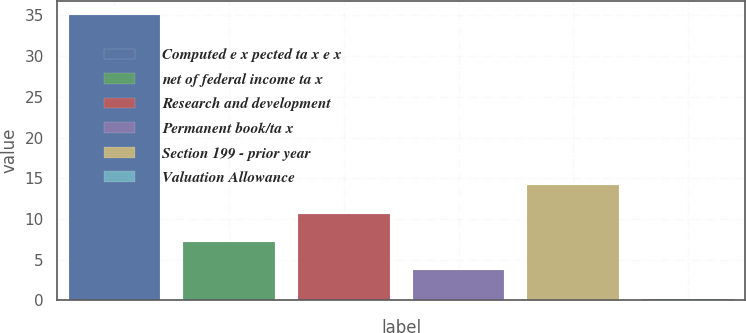Convert chart. <chart><loc_0><loc_0><loc_500><loc_500><bar_chart><fcel>Computed e x pected ta x e x<fcel>net of federal income ta x<fcel>Research and development<fcel>Permanent book/ta x<fcel>Section 199 - prior year<fcel>Valuation Allowance<nl><fcel>35<fcel>7.16<fcel>10.64<fcel>3.68<fcel>14.12<fcel>0.2<nl></chart> 